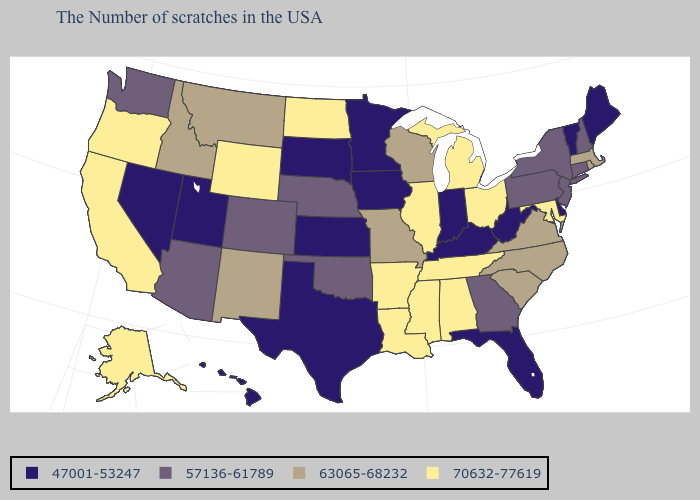Does Connecticut have a higher value than Michigan?
Keep it brief. No. What is the highest value in states that border West Virginia?
Be succinct. 70632-77619. Which states hav the highest value in the MidWest?
Write a very short answer. Ohio, Michigan, Illinois, North Dakota. Name the states that have a value in the range 63065-68232?
Concise answer only. Massachusetts, Rhode Island, Virginia, North Carolina, South Carolina, Wisconsin, Missouri, New Mexico, Montana, Idaho. What is the highest value in states that border Oregon?
Concise answer only. 70632-77619. Among the states that border Oregon , which have the highest value?
Be succinct. California. What is the highest value in the MidWest ?
Short answer required. 70632-77619. Does the map have missing data?
Keep it brief. No. Name the states that have a value in the range 47001-53247?
Short answer required. Maine, Vermont, Delaware, West Virginia, Florida, Kentucky, Indiana, Minnesota, Iowa, Kansas, Texas, South Dakota, Utah, Nevada, Hawaii. What is the lowest value in states that border New Hampshire?
Short answer required. 47001-53247. Name the states that have a value in the range 63065-68232?
Concise answer only. Massachusetts, Rhode Island, Virginia, North Carolina, South Carolina, Wisconsin, Missouri, New Mexico, Montana, Idaho. What is the value of Maine?
Concise answer only. 47001-53247. Does Arkansas have a higher value than Connecticut?
Write a very short answer. Yes. Among the states that border New Hampshire , does Massachusetts have the lowest value?
Quick response, please. No. Does the map have missing data?
Answer briefly. No. 